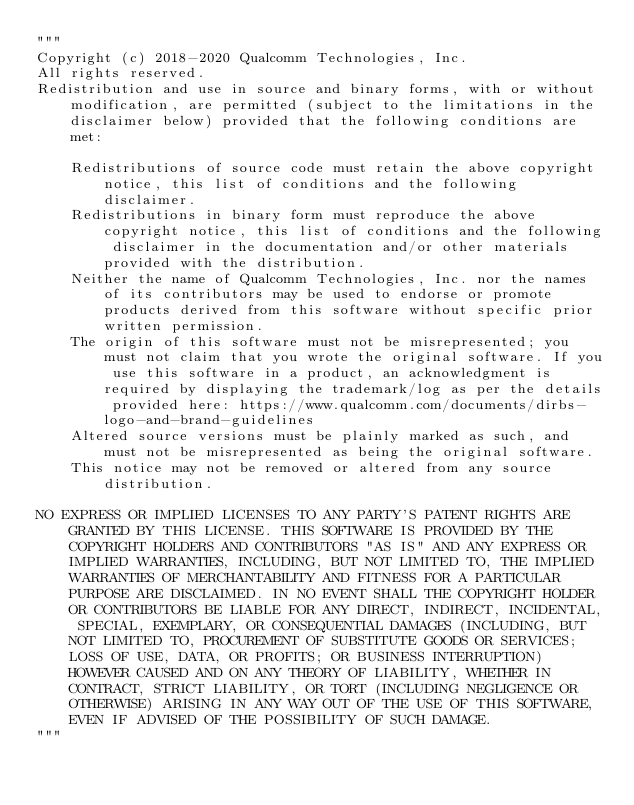Convert code to text. <code><loc_0><loc_0><loc_500><loc_500><_Python_>"""
Copyright (c) 2018-2020 Qualcomm Technologies, Inc.
All rights reserved.
Redistribution and use in source and binary forms, with or without modification, are permitted (subject to the limitations in the disclaimer below) provided that the following conditions are met:

    Redistributions of source code must retain the above copyright notice, this list of conditions and the following disclaimer.
    Redistributions in binary form must reproduce the above copyright notice, this list of conditions and the following disclaimer in the documentation and/or other materials provided with the distribution.
    Neither the name of Qualcomm Technologies, Inc. nor the names of its contributors may be used to endorse or promote products derived from this software without specific prior written permission.
    The origin of this software must not be misrepresented; you must not claim that you wrote the original software. If you use this software in a product, an acknowledgment is required by displaying the trademark/log as per the details provided here: https://www.qualcomm.com/documents/dirbs-logo-and-brand-guidelines
    Altered source versions must be plainly marked as such, and must not be misrepresented as being the original software.
    This notice may not be removed or altered from any source distribution.

NO EXPRESS OR IMPLIED LICENSES TO ANY PARTY'S PATENT RIGHTS ARE GRANTED BY THIS LICENSE. THIS SOFTWARE IS PROVIDED BY THE COPYRIGHT HOLDERS AND CONTRIBUTORS "AS IS" AND ANY EXPRESS OR IMPLIED WARRANTIES, INCLUDING, BUT NOT LIMITED TO, THE IMPLIED WARRANTIES OF MERCHANTABILITY AND FITNESS FOR A PARTICULAR PURPOSE ARE DISCLAIMED. IN NO EVENT SHALL THE COPYRIGHT HOLDER OR CONTRIBUTORS BE LIABLE FOR ANY DIRECT, INDIRECT, INCIDENTAL, SPECIAL, EXEMPLARY, OR CONSEQUENTIAL DAMAGES (INCLUDING, BUT NOT LIMITED TO, PROCUREMENT OF SUBSTITUTE GOODS OR SERVICES; LOSS OF USE, DATA, OR PROFITS; OR BUSINESS INTERRUPTION) HOWEVER CAUSED AND ON ANY THEORY OF LIABILITY, WHETHER IN CONTRACT, STRICT LIABILITY, OR TORT (INCLUDING NEGLIGENCE OR OTHERWISE) ARISING IN ANY WAY OUT OF THE USE OF THIS SOFTWARE, EVEN IF ADVISED OF THE POSSIBILITY OF SUCH DAMAGE.
"""</code> 